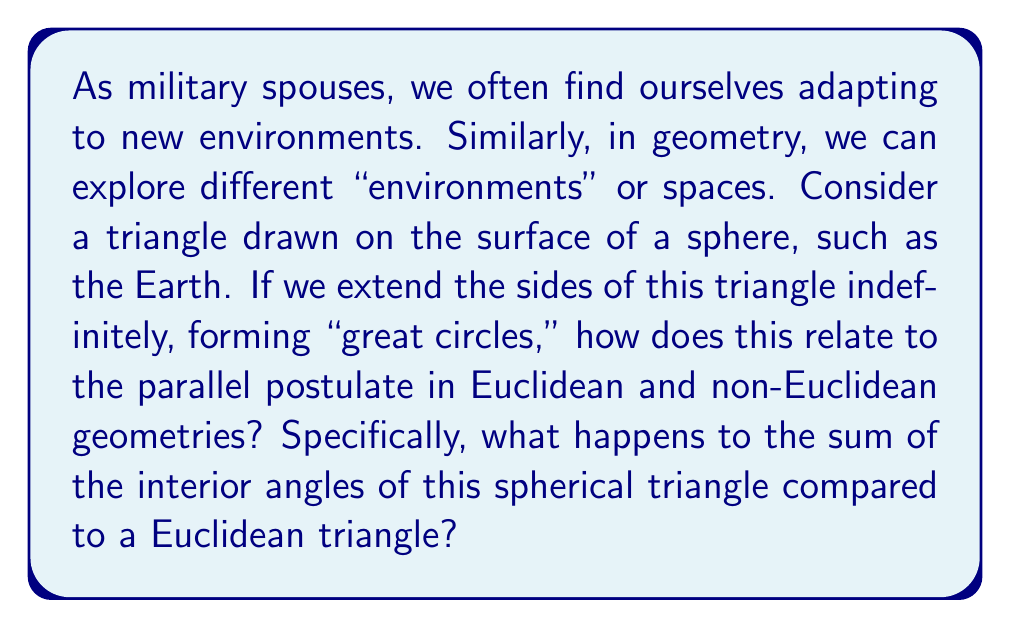Could you help me with this problem? Let's approach this step-by-step:

1) First, recall the parallel postulate in Euclidean geometry:
   Through a point not on a given line, there is exactly one line parallel to the given line.

2) On a sphere (which is a non-Euclidean surface), great circles are the equivalent of straight lines. These are circles on the sphere's surface whose centers coincide with the center of the sphere.

3) On a sphere, any two great circles always intersect at two antipodal points. This means there are no parallel lines on a sphere, violating the Euclidean parallel postulate.

4) Now, consider a triangle on a sphere:

   [asy]
   import geometry;

   size(200);
   
   real R = 100;
   triple A = (R,0,0), B = (0,R,0), C = (0,0,R);
   
   draw(arc(O,A,B), blue);
   draw(arc(O,B,C), red);
   draw(arc(O,C,A), green);
   
   dot("A", A, N);
   dot("B", B, W);
   dot("C", C, SE);
   [/asy]

5) In Euclidean geometry, the sum of the interior angles of a triangle is always 180°.

6) However, on a sphere, the sum of the interior angles of a triangle is always greater than 180°. The exact sum depends on the size of the triangle relative to the sphere.

7) The formula for the sum of angles in a spherical triangle is:

   $$ \alpha + \beta + \gamma = 180° + \frac{A}{R^2} \cdot \frac{180°}{\pi} $$

   Where $\alpha$, $\beta$, and $\gamma$ are the angles, $A$ is the area of the triangle, and $R$ is the radius of the sphere.

8) This excess over 180° is directly proportional to the area of the triangle. The larger the triangle (relative to the sphere's surface), the greater the sum of its angles.

This demonstrates a fundamental difference between Euclidean and spherical (non-Euclidean) geometry, stemming from the different nature of "straight lines" and the resulting violation of the parallel postulate in spherical geometry.
Answer: The sum of interior angles in a spherical triangle is always greater than 180°, unlike in Euclidean geometry where it's exactly 180°. 